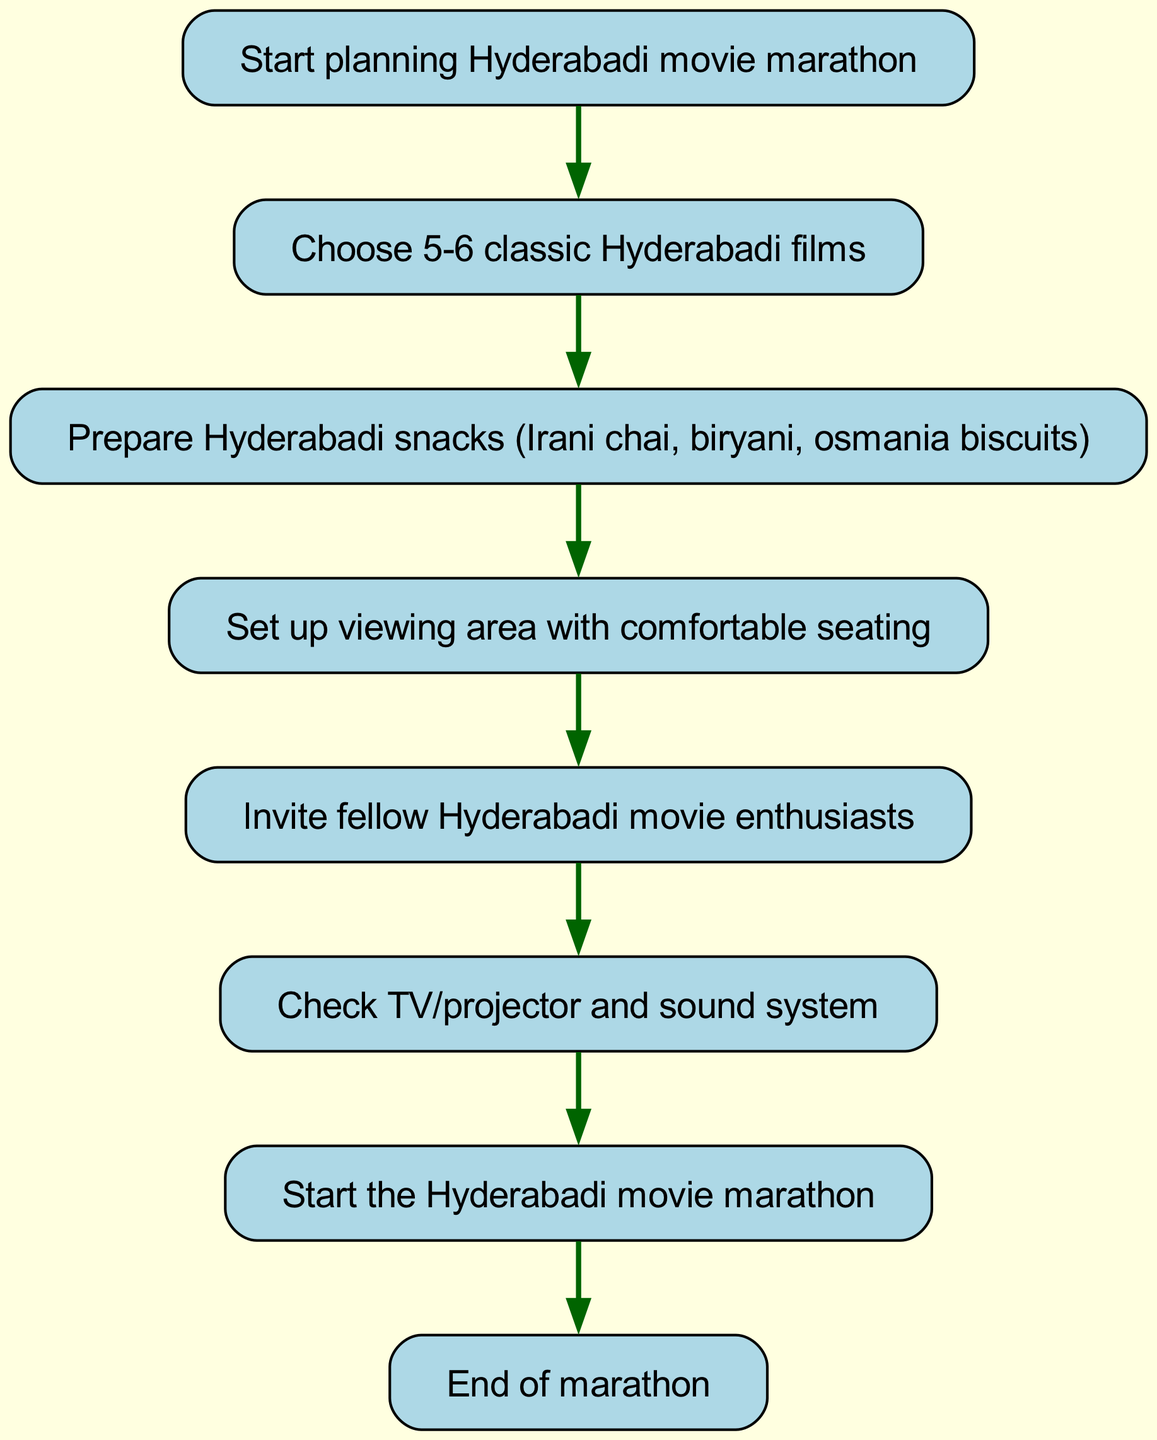What is the first step in organizing the Hyderabadi movie marathon? The first step, as shown in the diagram, is "Start planning Hyderabadi movie marathon". This is indicated as the starting node of the flowchart.
Answer: Start planning Hyderabadi movie marathon How many classic Hyderabadi films should be chosen? The diagram specifies that 5-6 classic Hyderabadi films should be chosen. This is indicated in the second step of the flowchart.
Answer: 5-6 classic Hyderabadi films Which step comes after preparing the snacks? The next step after "Prepare Hyderabadi snacks (Irani chai, biryani, osmania biscuits)" is "Set up viewing area with comfortable seating". This is a direct connection from one node to the next in the flowchart.
Answer: Set up viewing area with comfortable seating What is the last action before the movie marathon starts? The last action before starting the marathon is "Check TV/projector and sound system". This comes right before the final step in the diagram.
Answer: Check TV/projector and sound system Which stage involves inviting friends? The stage that involves inviting friends is "Invite fellow Hyderabadi movie enthusiasts". This is shown as an intermediate step in the flowchart.
Answer: Invite fellow Hyderabadi movie enthusiasts How many total nodes are in this flowchart? The total number of nodes in the flowchart is 8. This includes all steps from start to end, including all actions needed to organize the movie marathon.
Answer: 8 What links the "setup space" and "invite friends" nodes? The connection that links these two nodes is the action "Set up viewing area with comfortable seating" leading to "Invite fellow Hyderabadi movie enthusiasts". This indicates the sequence of steps.
Answer: Set up viewing area with comfortable seating Can you name the snack to prepare during the organizing process? One of the snacks mentioned in the flowchart to prepare is "Irani chai". This is included in the snack preparation step.
Answer: Irani chai What is the endpoint of this flowchart? The endpoint of the flowchart is labeled as "End of marathon". This signifies the completion of the planning and execution process laid out in the chart.
Answer: End of marathon 